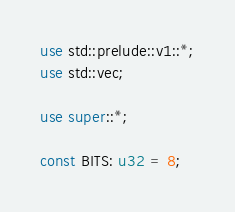Convert code to text. <code><loc_0><loc_0><loc_500><loc_500><_Rust_>use std::prelude::v1::*;
use std::vec;

use super::*;

const BITS: u32 = 8;
</code> 